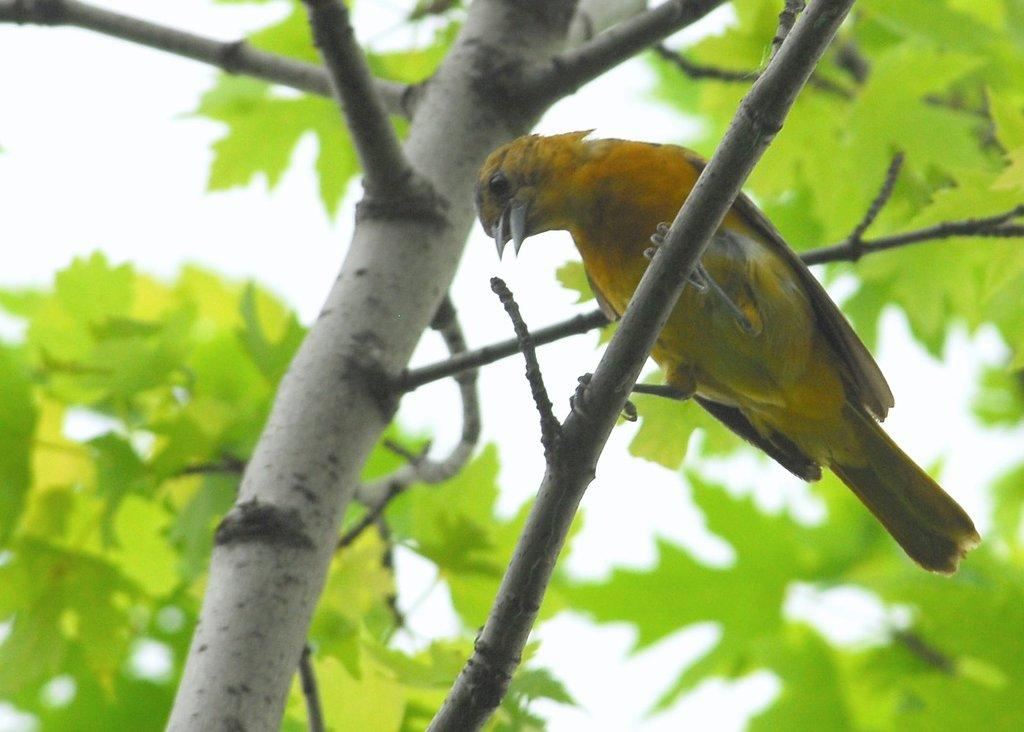What type of animal is in the image? There is a yellow bird in the image. Where is the bird located in the image? The bird is sitting on a tree branch. What color are the leaves visible in the image? The leaves are green. What type of mitten is the bird wearing in the image? There is no mitten present in the image, and the bird is not wearing any clothing. What songs is the bird singing in the image? The image does not provide any information about the bird singing songs. 